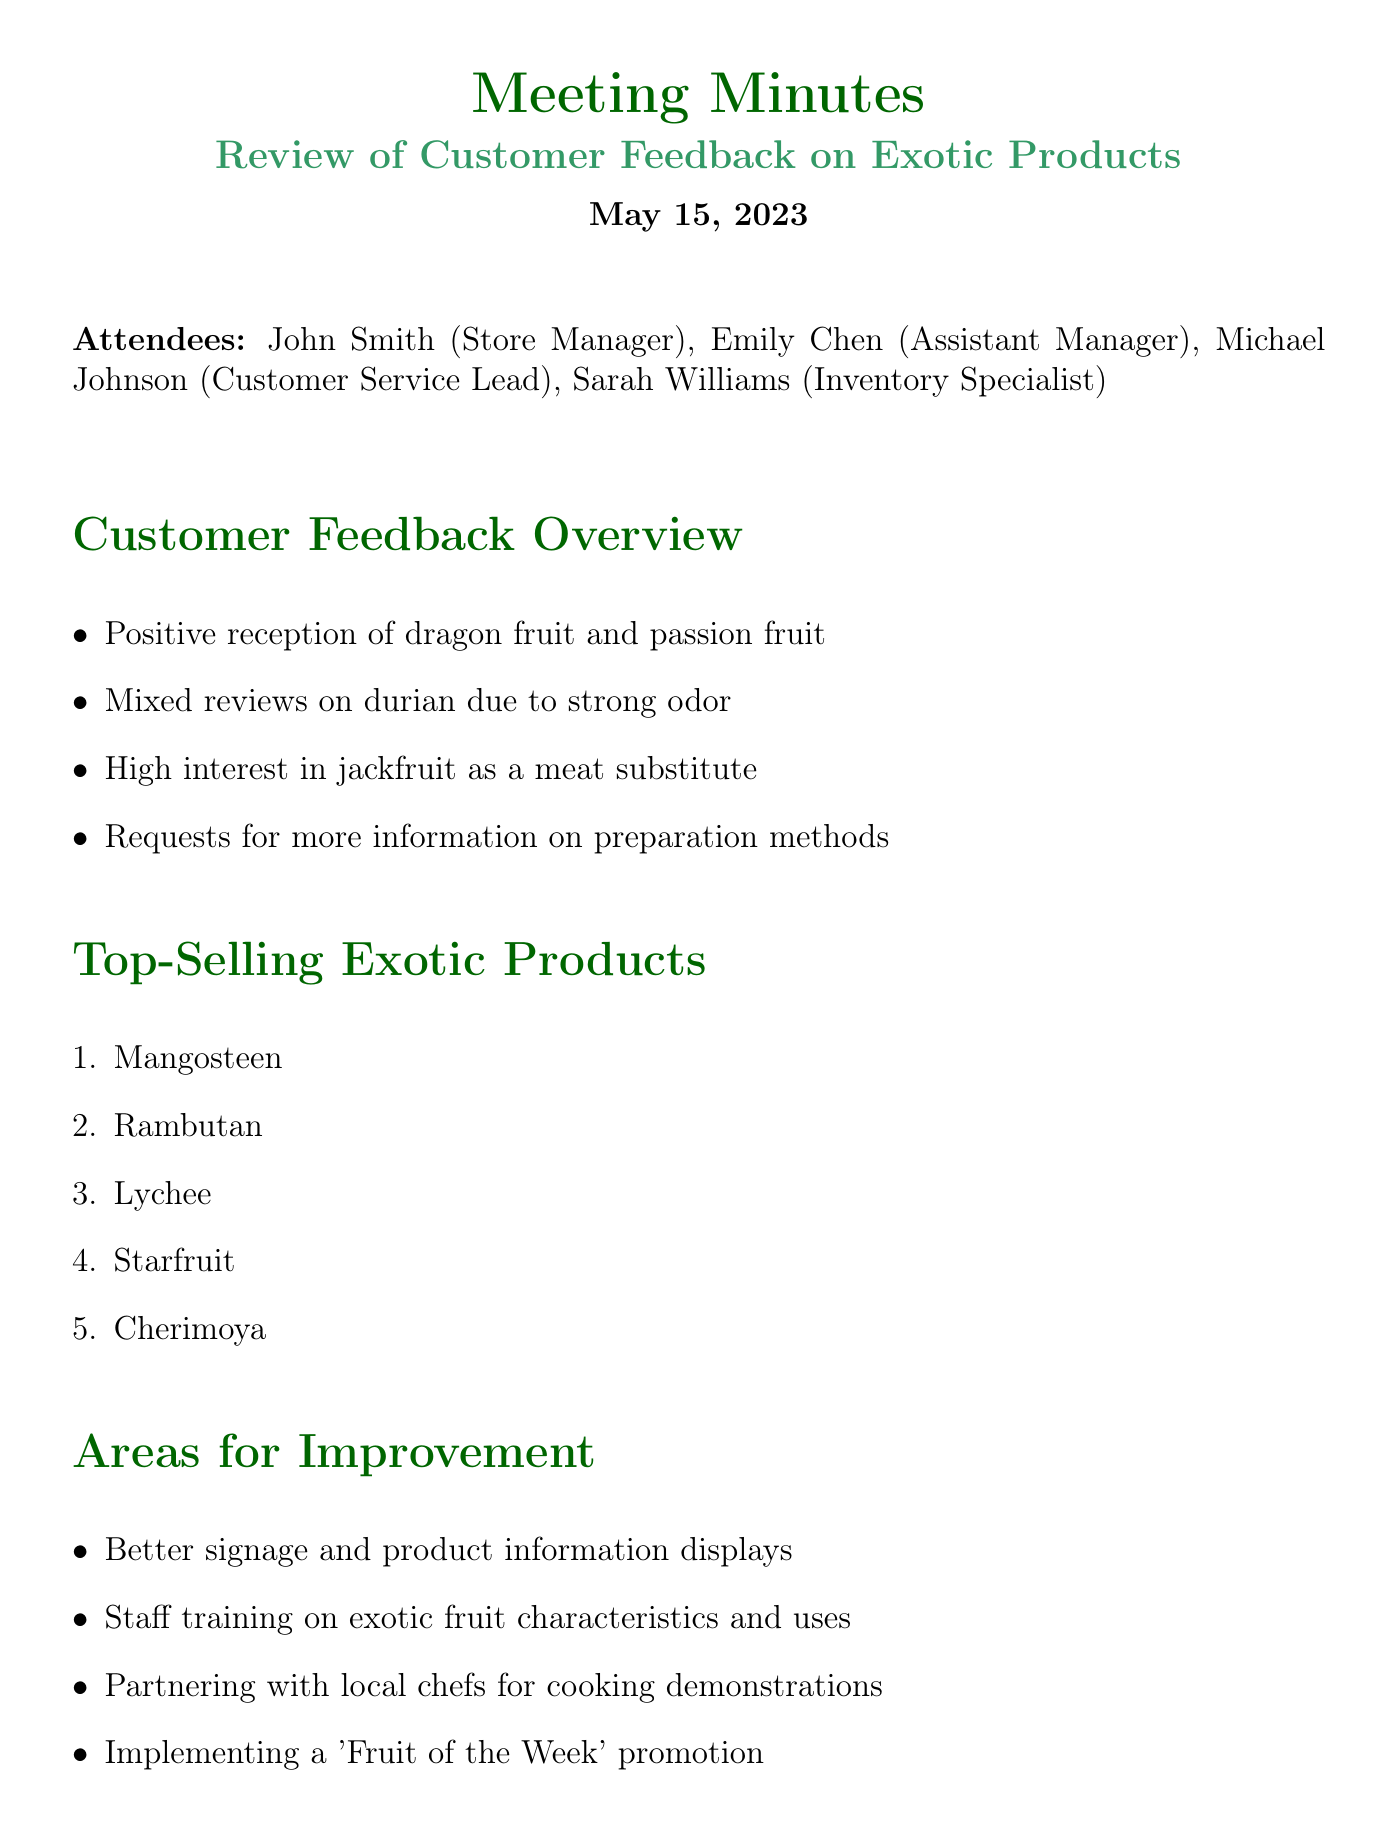What is the date of the meeting? The date of the meeting is explicitly mentioned in the document.
Answer: May 15, 2023 Who is the Store Manager? The Store Manager's name is listed among the attendees of the meeting.
Answer: John Smith What are the top-selling exotic products? A specific list is provided in the document, detailing the top items.
Answer: Mangosteen, Rambutan, Lychee, Starfruit, Cherimoya What is a recommended area for improvement? Areas for improvement are presented in a bullet point format in the document.
Answer: Better signage and product information displays How many action items are listed? The total number of action items is found by counting the items under the action section.
Answer: 4 Which exotic product received mixed reviews? The document specifically notes customer feedback on this product.
Answer: Durian What is one proposed next step? The next steps are outlined succinctly in the document.
Answer: Review inventory levels and adjust ordering based on sales data What was the reception of dragon fruit? There is specific feedback regarding this product in the overview.
Answer: Positive reception Is there a proposal for a promotional campaign? The document suggests promotional strategies under the action items section.
Answer: Develop social media campaign highlighting customer reviews and recipe ideas 